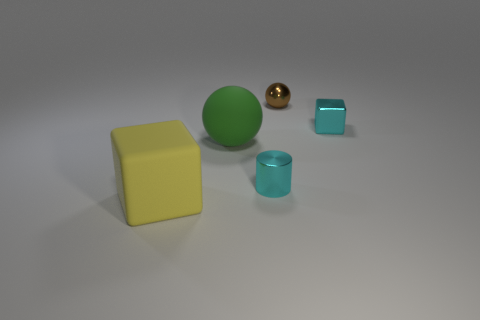What number of objects are either big objects that are behind the matte block or large blue matte things?
Provide a short and direct response. 1. Is there a big ball of the same color as the cylinder?
Keep it short and to the point. No. There is a big yellow object; is it the same shape as the metal thing that is in front of the big ball?
Your answer should be compact. No. How many objects are on the left side of the large green ball and right of the brown metal sphere?
Keep it short and to the point. 0. What is the material of the other thing that is the same shape as the large green rubber object?
Your answer should be very brief. Metal. There is a cube on the left side of the rubber thing that is behind the yellow matte object; what size is it?
Provide a short and direct response. Large. Are there any metallic blocks?
Offer a terse response. Yes. There is a object that is to the right of the large green matte thing and in front of the metallic block; what is its material?
Keep it short and to the point. Metal. Are there more cubes in front of the shiny sphere than things in front of the matte sphere?
Ensure brevity in your answer.  No. Are there any yellow things of the same size as the green object?
Ensure brevity in your answer.  Yes. 